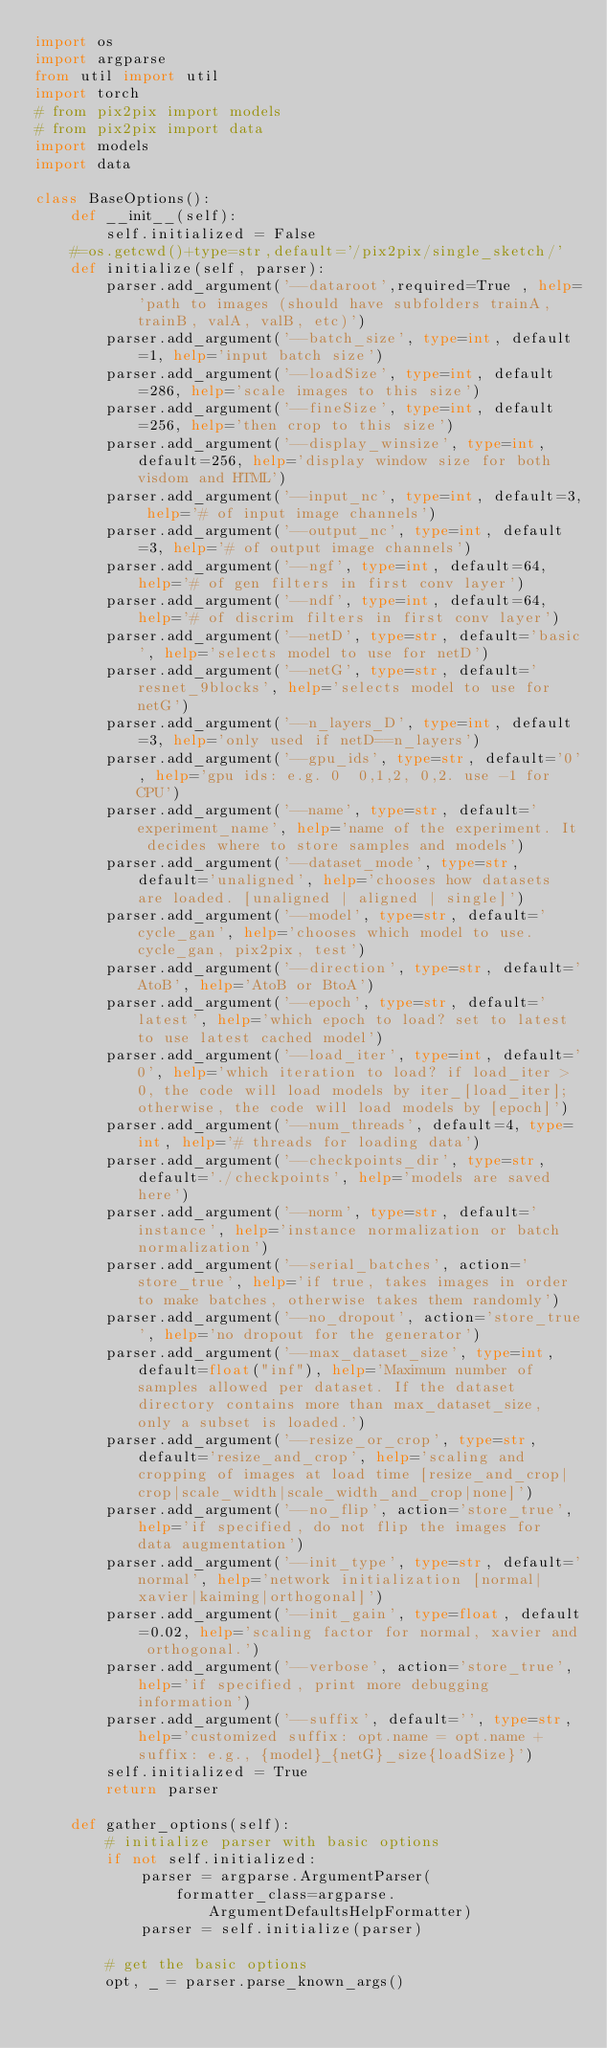Convert code to text. <code><loc_0><loc_0><loc_500><loc_500><_Python_>import os
import argparse
from util import util
import torch
# from pix2pix import models
# from pix2pix import data
import models
import data

class BaseOptions():
    def __init__(self):
        self.initialized = False
    #=os.getcwd()+type=str,default='/pix2pix/single_sketch/'
    def initialize(self, parser):
        parser.add_argument('--dataroot',required=True , help='path to images (should have subfolders trainA, trainB, valA, valB, etc)')
        parser.add_argument('--batch_size', type=int, default=1, help='input batch size')
        parser.add_argument('--loadSize', type=int, default=286, help='scale images to this size')
        parser.add_argument('--fineSize', type=int, default=256, help='then crop to this size')
        parser.add_argument('--display_winsize', type=int, default=256, help='display window size for both visdom and HTML')
        parser.add_argument('--input_nc', type=int, default=3, help='# of input image channels')
        parser.add_argument('--output_nc', type=int, default=3, help='# of output image channels')
        parser.add_argument('--ngf', type=int, default=64, help='# of gen filters in first conv layer')
        parser.add_argument('--ndf', type=int, default=64, help='# of discrim filters in first conv layer')
        parser.add_argument('--netD', type=str, default='basic', help='selects model to use for netD')
        parser.add_argument('--netG', type=str, default='resnet_9blocks', help='selects model to use for netG')
        parser.add_argument('--n_layers_D', type=int, default=3, help='only used if netD==n_layers')
        parser.add_argument('--gpu_ids', type=str, default='0', help='gpu ids: e.g. 0  0,1,2, 0,2. use -1 for CPU')
        parser.add_argument('--name', type=str, default='experiment_name', help='name of the experiment. It decides where to store samples and models')
        parser.add_argument('--dataset_mode', type=str, default='unaligned', help='chooses how datasets are loaded. [unaligned | aligned | single]')
        parser.add_argument('--model', type=str, default='cycle_gan', help='chooses which model to use. cycle_gan, pix2pix, test')
        parser.add_argument('--direction', type=str, default='AtoB', help='AtoB or BtoA')
        parser.add_argument('--epoch', type=str, default='latest', help='which epoch to load? set to latest to use latest cached model')
        parser.add_argument('--load_iter', type=int, default='0', help='which iteration to load? if load_iter > 0, the code will load models by iter_[load_iter]; otherwise, the code will load models by [epoch]')
        parser.add_argument('--num_threads', default=4, type=int, help='# threads for loading data')
        parser.add_argument('--checkpoints_dir', type=str, default='./checkpoints', help='models are saved here')
        parser.add_argument('--norm', type=str, default='instance', help='instance normalization or batch normalization')
        parser.add_argument('--serial_batches', action='store_true', help='if true, takes images in order to make batches, otherwise takes them randomly')
        parser.add_argument('--no_dropout', action='store_true', help='no dropout for the generator')
        parser.add_argument('--max_dataset_size', type=int, default=float("inf"), help='Maximum number of samples allowed per dataset. If the dataset directory contains more than max_dataset_size, only a subset is loaded.')
        parser.add_argument('--resize_or_crop', type=str, default='resize_and_crop', help='scaling and cropping of images at load time [resize_and_crop|crop|scale_width|scale_width_and_crop|none]')
        parser.add_argument('--no_flip', action='store_true', help='if specified, do not flip the images for data augmentation')
        parser.add_argument('--init_type', type=str, default='normal', help='network initialization [normal|xavier|kaiming|orthogonal]')
        parser.add_argument('--init_gain', type=float, default=0.02, help='scaling factor for normal, xavier and orthogonal.')
        parser.add_argument('--verbose', action='store_true', help='if specified, print more debugging information')
        parser.add_argument('--suffix', default='', type=str, help='customized suffix: opt.name = opt.name + suffix: e.g., {model}_{netG}_size{loadSize}')
        self.initialized = True
        return parser

    def gather_options(self):
        # initialize parser with basic options
        if not self.initialized:
            parser = argparse.ArgumentParser(
                formatter_class=argparse.ArgumentDefaultsHelpFormatter)
            parser = self.initialize(parser)

        # get the basic options
        opt, _ = parser.parse_known_args()
</code> 